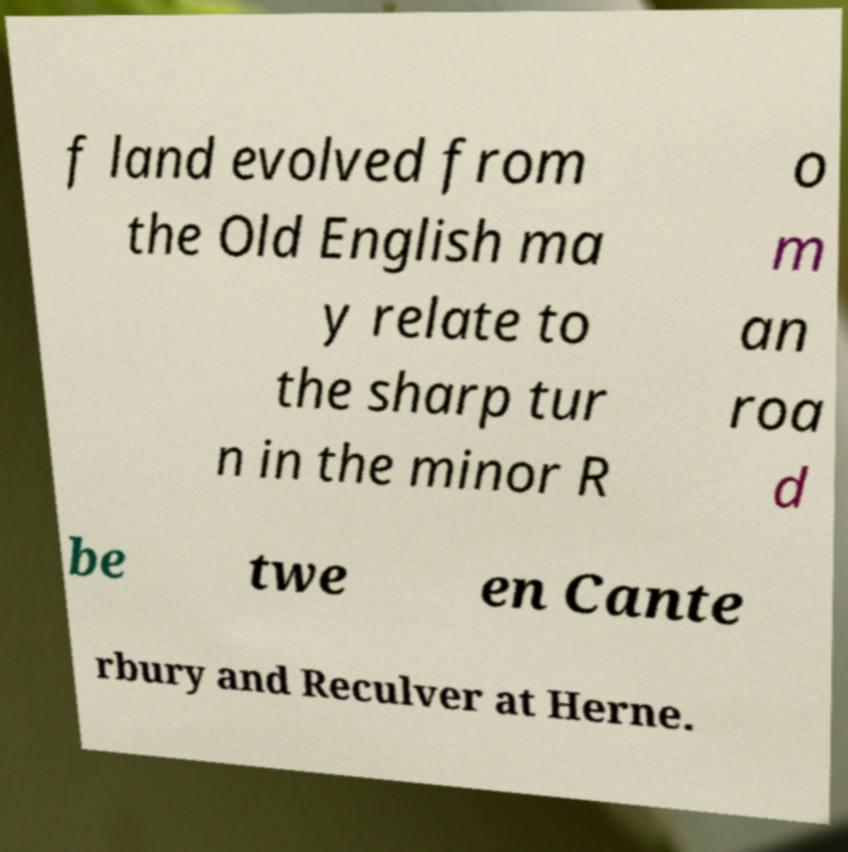Please read and relay the text visible in this image. What does it say? f land evolved from the Old English ma y relate to the sharp tur n in the minor R o m an roa d be twe en Cante rbury and Reculver at Herne. 